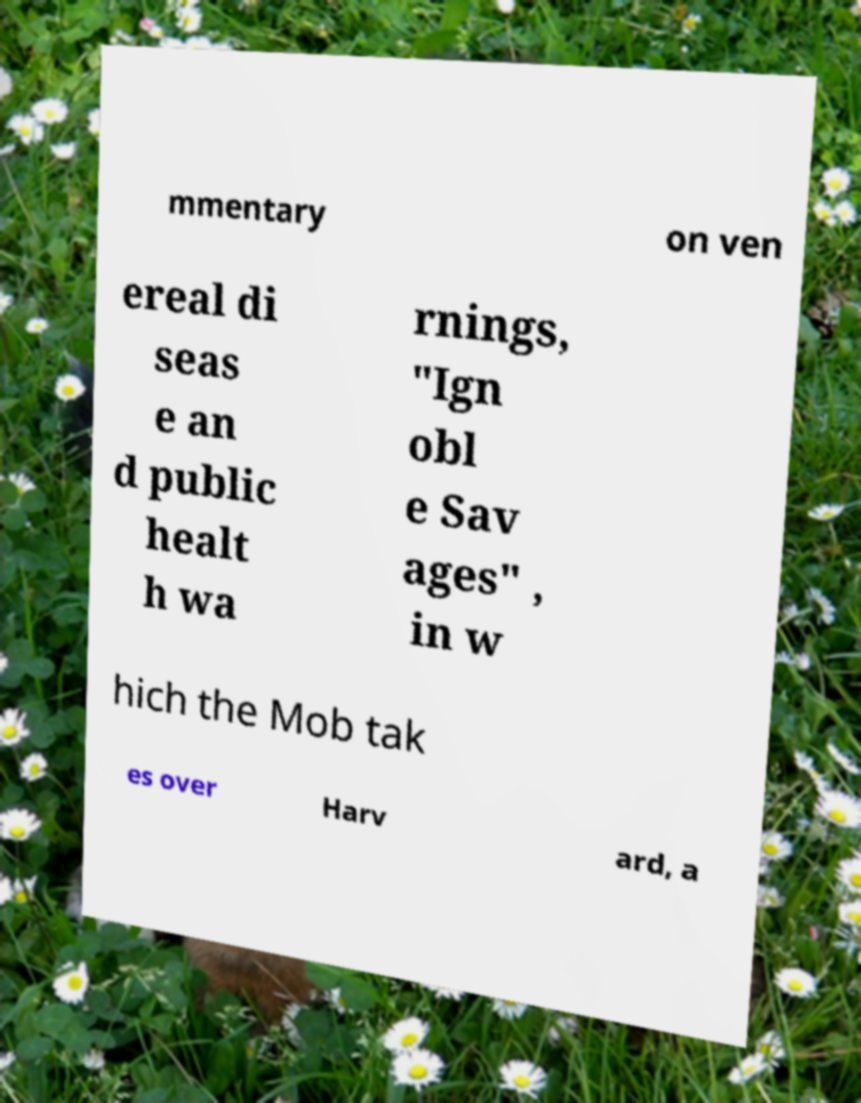What messages or text are displayed in this image? I need them in a readable, typed format. mmentary on ven ereal di seas e an d public healt h wa rnings, "Ign obl e Sav ages" , in w hich the Mob tak es over Harv ard, a 